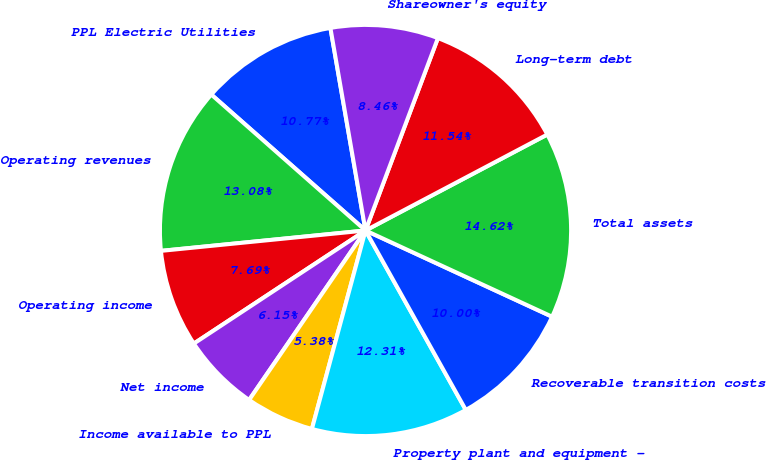Convert chart to OTSL. <chart><loc_0><loc_0><loc_500><loc_500><pie_chart><fcel>PPL Electric Utilities<fcel>Operating revenues<fcel>Operating income<fcel>Net income<fcel>Income available to PPL<fcel>Property plant and equipment -<fcel>Recoverable transition costs<fcel>Total assets<fcel>Long-term debt<fcel>Shareowner's equity<nl><fcel>10.77%<fcel>13.08%<fcel>7.69%<fcel>6.15%<fcel>5.38%<fcel>12.31%<fcel>10.0%<fcel>14.62%<fcel>11.54%<fcel>8.46%<nl></chart> 